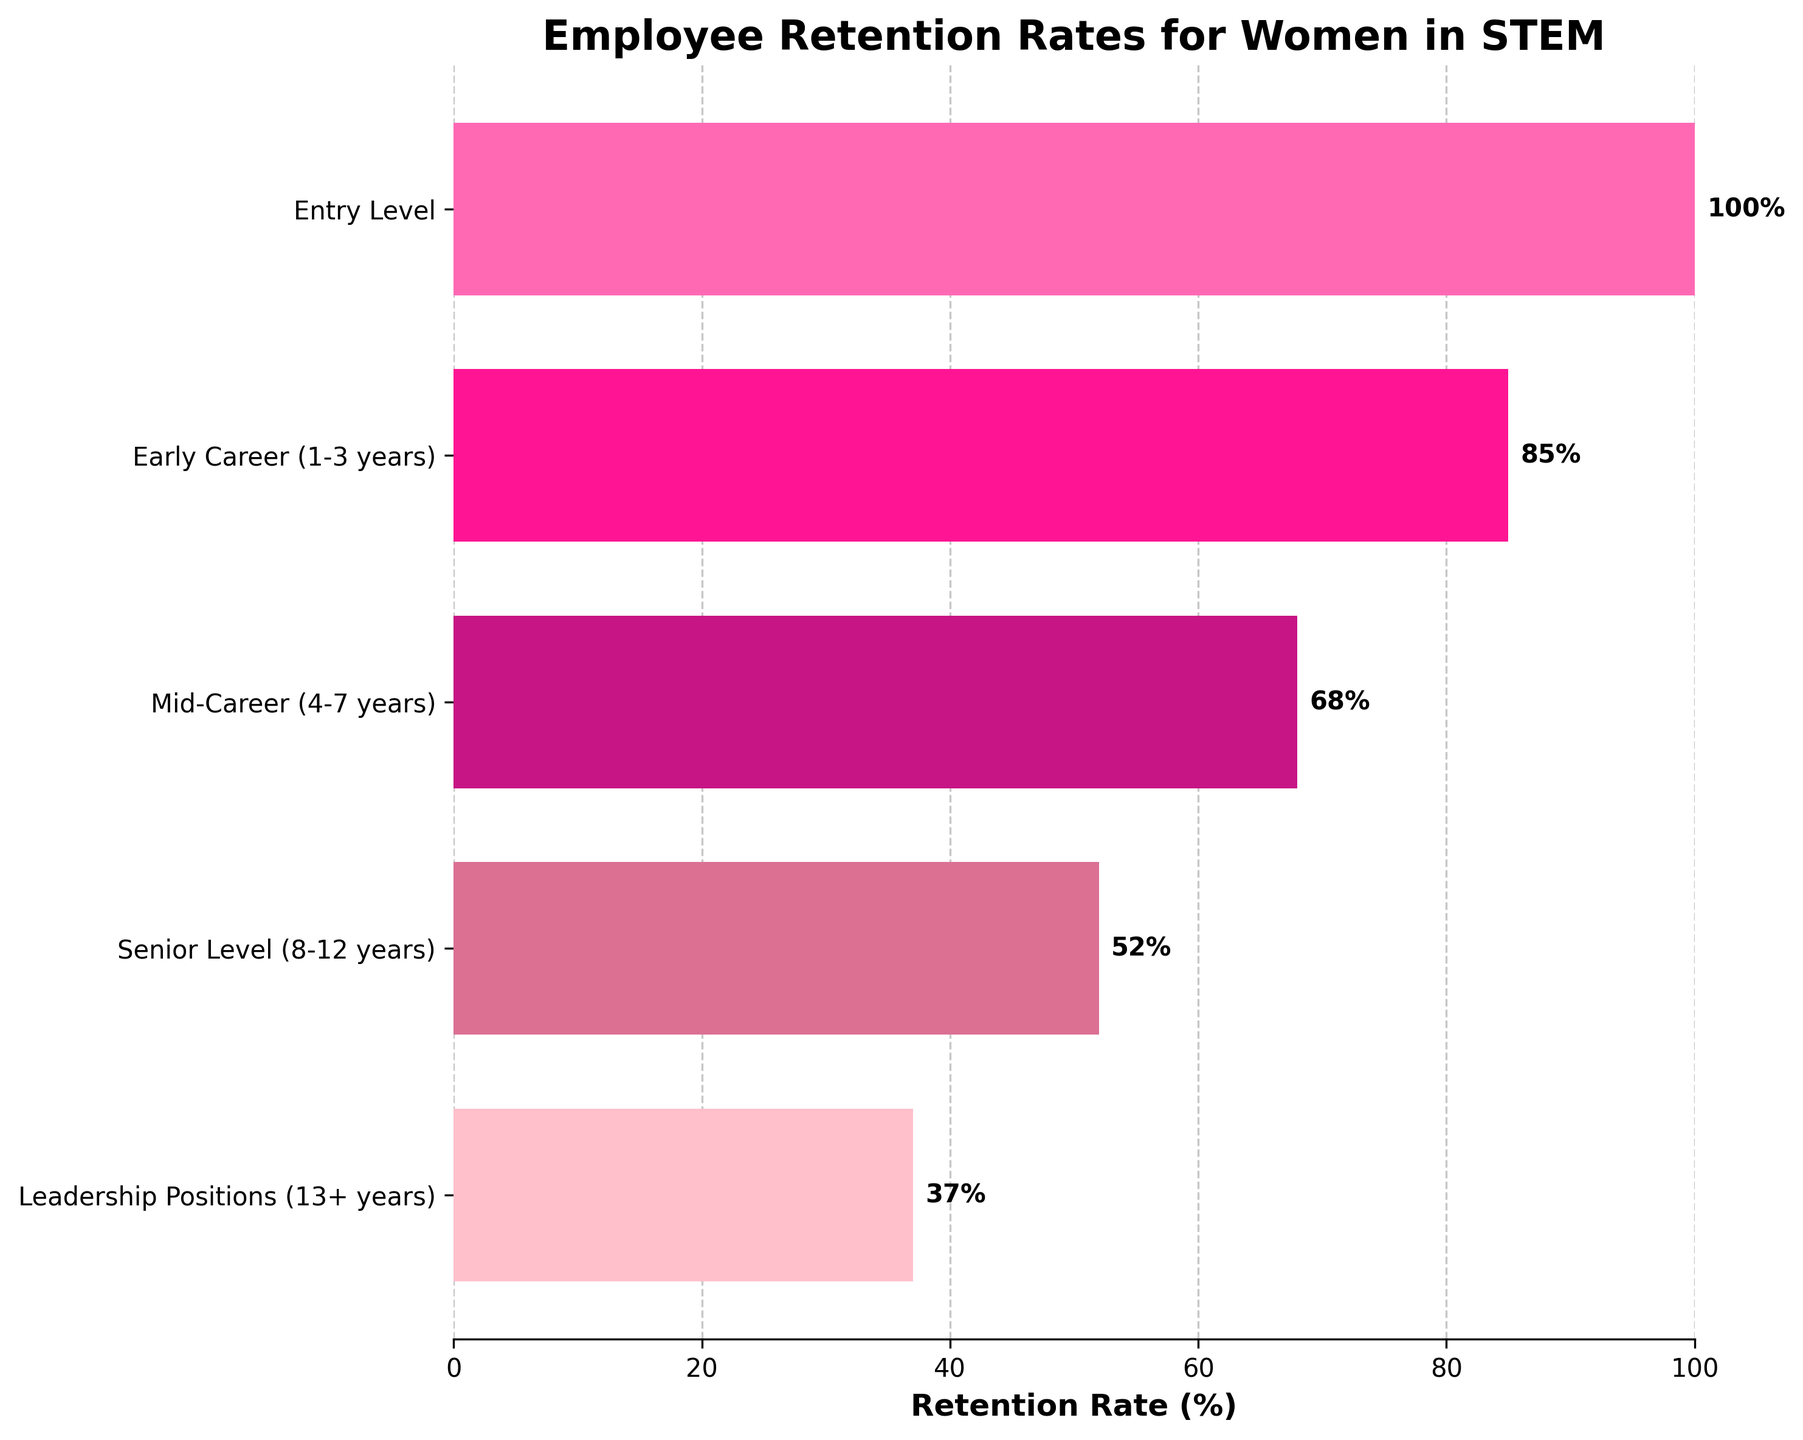What is the title of the funnel chart? The title is located at the top of the chart, and indicates the main focus of the data being visualized. The title is "Employee Retention Rates for Women in STEM."
Answer: Employee Retention Rates for Women in STEM How many career stages are represented in the chart? The horizontal bars represent different career stages. Each bar corresponds to a different stage, and there are five bars in total.
Answer: Five What is the retention rate at the senior level (8-12 years)? Look at the horizontal bar labeled "Senior Level (8-12 years)," and read the value at the end of the bar. The retention rate is 52%.
Answer: 52% By how much does the retention rate decrease from the entry level to early career (1-3 years)? To determine the decrease, subtract the retention rate at the early career stage from the retention rate at the entry level. The values are 100% for entry level and 85% for early career. So, 100% - 85% = 15%.
Answer: 15% Which career stage has the lowest retention rate? Identify the bar with the smallest value on the x-axis. The lowest retention rate, 37%, is at the "Leadership Positions (13+ years)" stage.
Answer: Leadership Positions (13+ years) What is the average retention rate across all career stages? Add the retention rates for all five stages and then divide by the number of stages. (100% + 85% + 68% + 52% + 37%) / 5 = 68.4%.
Answer: 68.4% How does the retention rate change as one progresses from mid-career (4-7 years) to leadership positions (13+ years)? Look at the retention rates for mid-career (68%) and leadership positions (37%), and calculate the difference. The rate decreases from 68% to 37%, a drop of 31%.
Answer: Decreases by 31% What is the largest drop in retention rate between any consecutive career stages? Calculate the differences between consecutive stages: Entry to Early (15%), Early to Mid (17%), Mid to Senior (16%), Senior to Leadership (15%). The largest is "Early Career (1-3 years)" to "Mid-Career (4-7 years)" with 17%.
Answer: 17% How does the retention rate at early career stage compare to that at senior level stage? Compare the retention rates of early career (85%) and senior level (52%). The retention rate is higher at the early career stage.
Answer: Higher at early career stage 